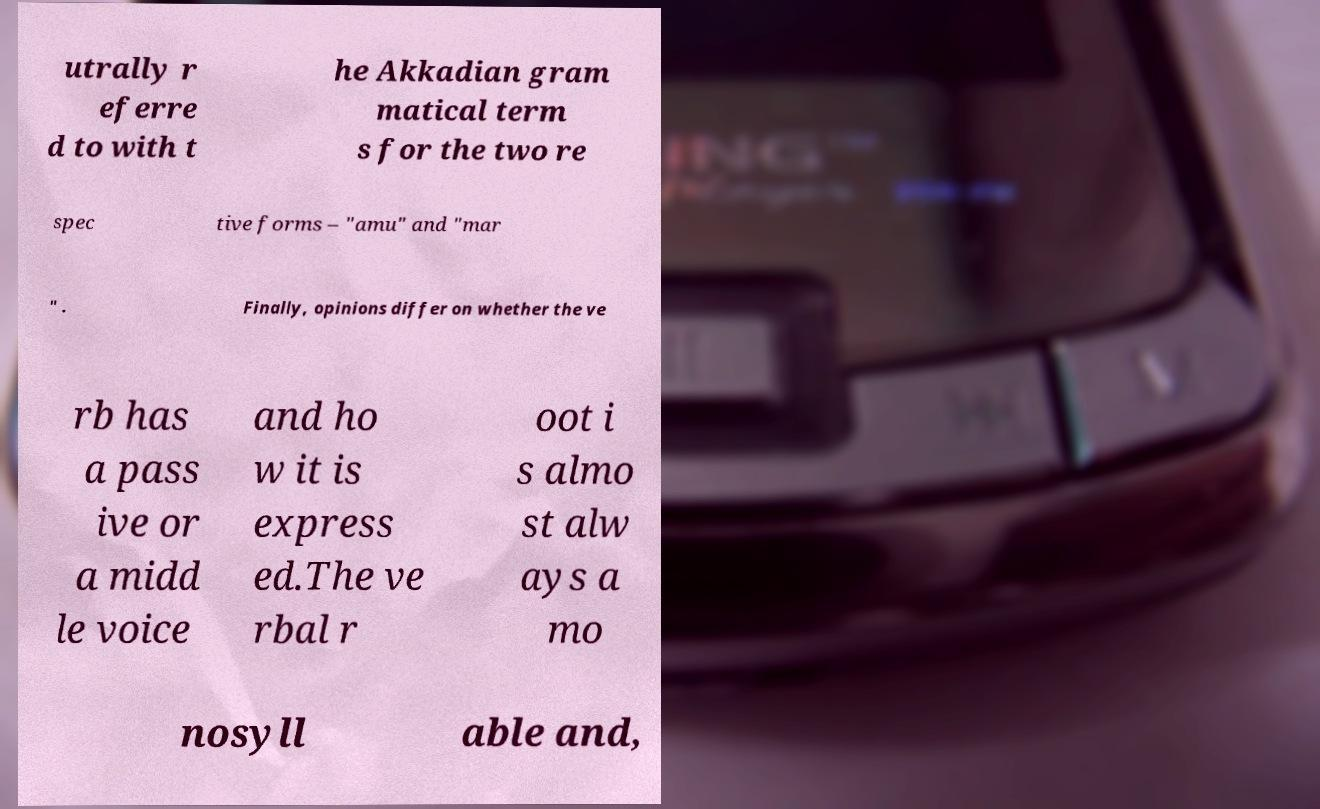I need the written content from this picture converted into text. Can you do that? utrally r eferre d to with t he Akkadian gram matical term s for the two re spec tive forms – "amu" and "mar " . Finally, opinions differ on whether the ve rb has a pass ive or a midd le voice and ho w it is express ed.The ve rbal r oot i s almo st alw ays a mo nosyll able and, 